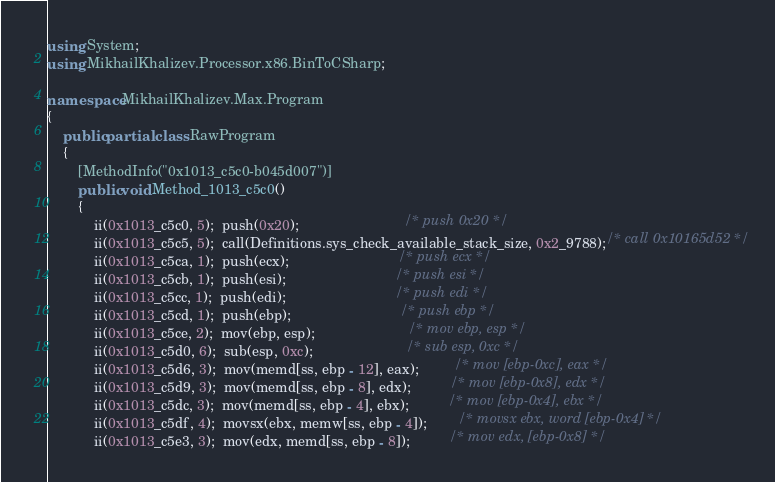Convert code to text. <code><loc_0><loc_0><loc_500><loc_500><_C#_>using System;
using MikhailKhalizev.Processor.x86.BinToCSharp;

namespace MikhailKhalizev.Max.Program
{
    public partial class RawProgram
    {
        [MethodInfo("0x1013_c5c0-b045d007")]
        public void Method_1013_c5c0()
        {
            ii(0x1013_c5c0, 5);  push(0x20);                           /* push 0x20 */
            ii(0x1013_c5c5, 5);  call(Definitions.sys_check_available_stack_size, 0x2_9788);/* call 0x10165d52 */
            ii(0x1013_c5ca, 1);  push(ecx);                            /* push ecx */
            ii(0x1013_c5cb, 1);  push(esi);                            /* push esi */
            ii(0x1013_c5cc, 1);  push(edi);                            /* push edi */
            ii(0x1013_c5cd, 1);  push(ebp);                            /* push ebp */
            ii(0x1013_c5ce, 2);  mov(ebp, esp);                        /* mov ebp, esp */
            ii(0x1013_c5d0, 6);  sub(esp, 0xc);                        /* sub esp, 0xc */
            ii(0x1013_c5d6, 3);  mov(memd[ss, ebp - 12], eax);         /* mov [ebp-0xc], eax */
            ii(0x1013_c5d9, 3);  mov(memd[ss, ebp - 8], edx);          /* mov [ebp-0x8], edx */
            ii(0x1013_c5dc, 3);  mov(memd[ss, ebp - 4], ebx);          /* mov [ebp-0x4], ebx */
            ii(0x1013_c5df, 4);  movsx(ebx, memw[ss, ebp - 4]);        /* movsx ebx, word [ebp-0x4] */
            ii(0x1013_c5e3, 3);  mov(edx, memd[ss, ebp - 8]);          /* mov edx, [ebp-0x8] */</code> 